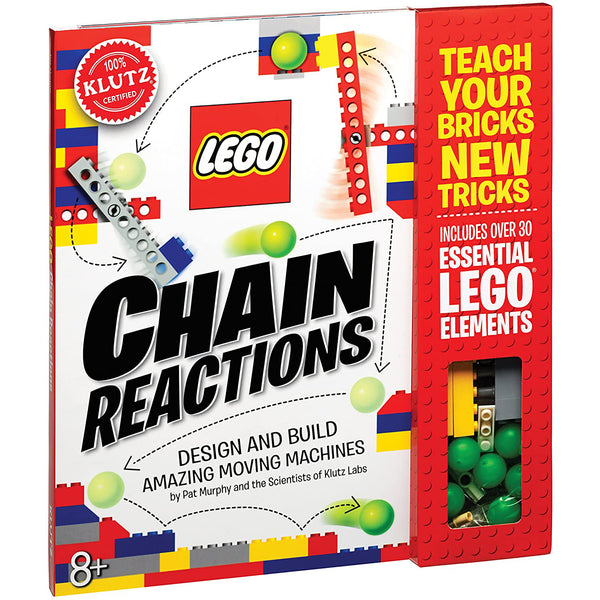Can you propose a simple project using this LEGO set that could help demonstrate the concept of potential and kinetic energy? A fascinating project to demonstrate potential and kinetic energy with the LEGO 'Chain Reactions' set would be a 'Ball Drop Roller Coaster.' Start by building a series of inclined planes and tracks using the elements in the set. Place a ball at the highest point, where it has maximum potential energy. As the ball rolls down, this energy converts into kinetic energy, observable as the ball accelerates. To enhance the learning, add stops where the ball momentarily pauses, showing how kinetic converts back into potential energy. This real-time visualization helps in understanding energy dynamics in physical systems. 